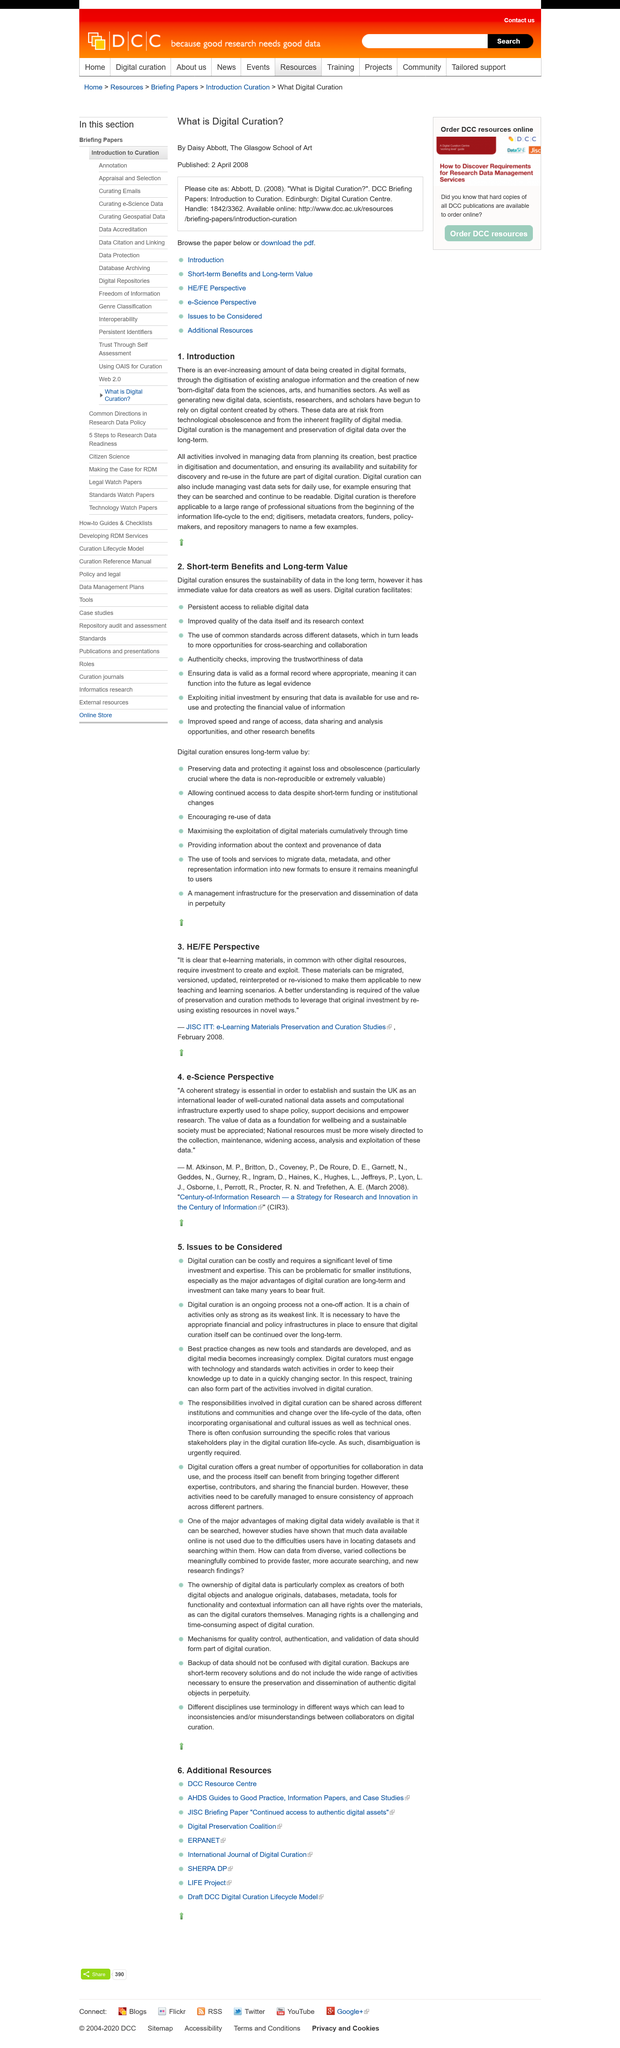List a handful of essential elements in this visual. Digital curation is the management and preservation of digital data for long-term use and access. Daisy Abbott is the author of the article "What is Digital Curation. Digital content created by others is relied upon by scientists, researchers, and scholars. Daisy Abbott is a student of the Glasgow School of Art. She is known for her talent and creativity in the field of art. The article 'What is Digital Curation?' was first published on April 2, 2008. 